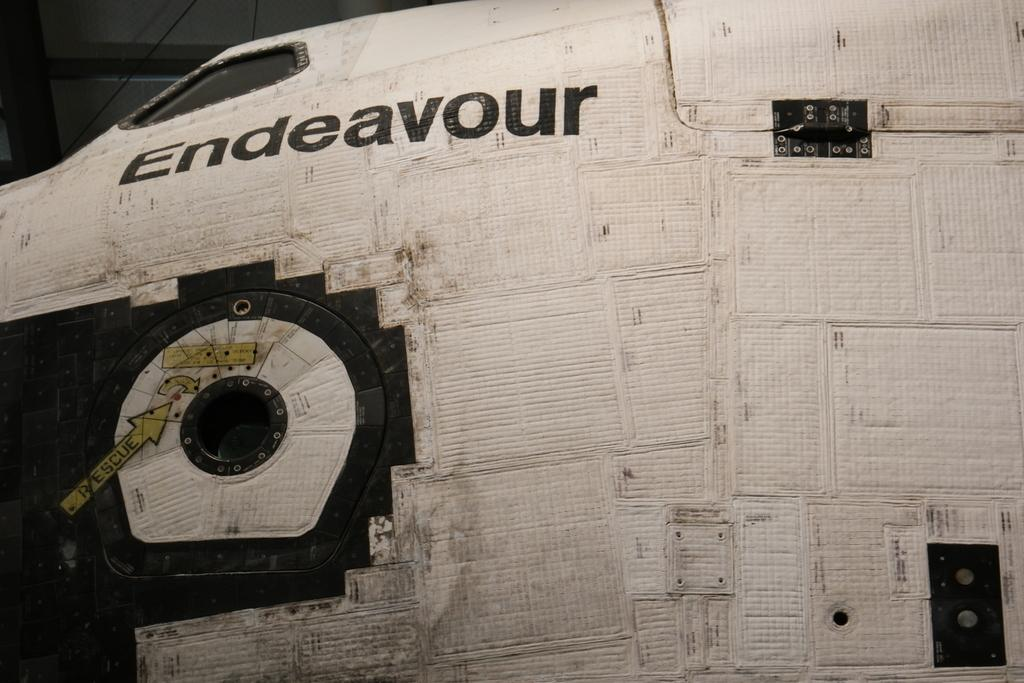<image>
Provide a brief description of the given image. A side view of the space shuttle Endeavour 